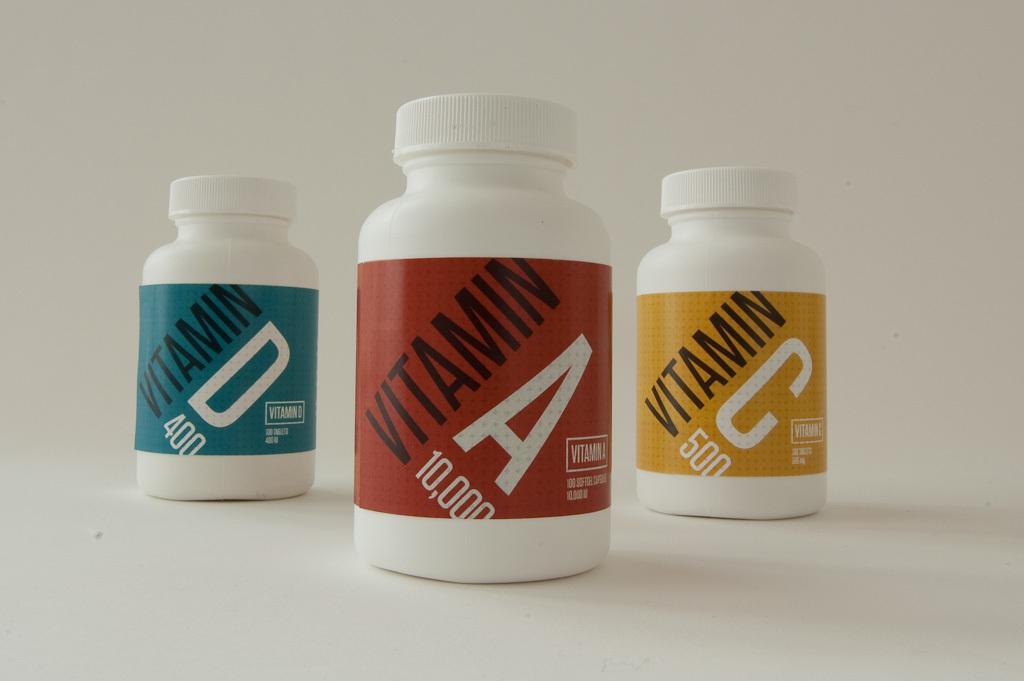Describe this image in one or two sentences. There are three vitamin bottles where vitamin A is red in color,vitamin C is yellow in color and vitamin D is blue in color. 